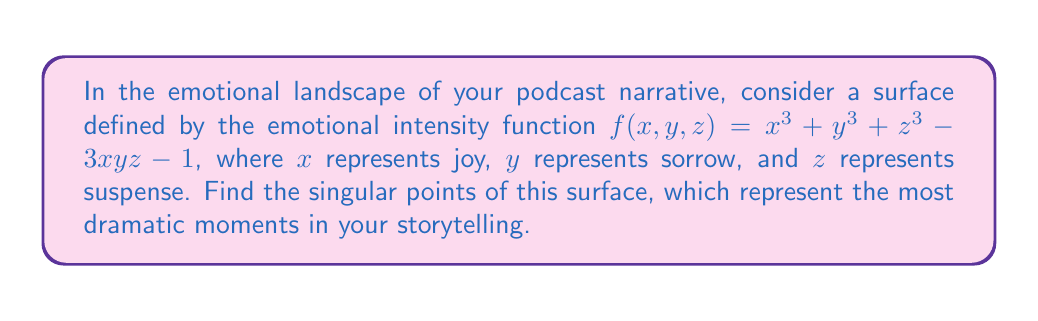Show me your answer to this math problem. To find the singular points of the surface, we need to follow these steps:

1) The singular points are those where all partial derivatives of $f$ are zero simultaneously. Let's calculate these partial derivatives:

   $\frac{\partial f}{\partial x} = 3x^2 - 3yz$
   $\frac{\partial f}{\partial y} = 3y^2 - 3xz$
   $\frac{\partial f}{\partial z} = 3z^2 - 3xy$

2) Set each of these equal to zero:

   $3x^2 - 3yz = 0$
   $3y^2 - 3xz = 0$
   $3z^2 - 3xy = 0$

3) Divide each equation by 3:

   $x^2 = yz$
   $y^2 = xz$
   $z^2 = xy$

4) From these equations, we can deduce that either $x = y = z = 0$, or $x = y = z = 1$, or $x = y = z = -1$.

5) Let's check which of these satisfy the original equation $f(x,y,z) = x^3 + y^3 + z^3 - 3xyz - 1 = 0$:

   For $(0,0,0)$: $f(0,0,0) = -1 \neq 0$
   For $(1,1,1)$: $f(1,1,1) = 1 + 1 + 1 - 3 - 1 = -1 \neq 0$
   For $(-1,-1,-1)$: $f(-1,-1,-1) = -1 - 1 - 1 + 3 - 1 = -1 \neq 0$

6) Since none of these points satisfy the original equation, there are no real singular points for this surface.
Answer: No real singular points exist. 